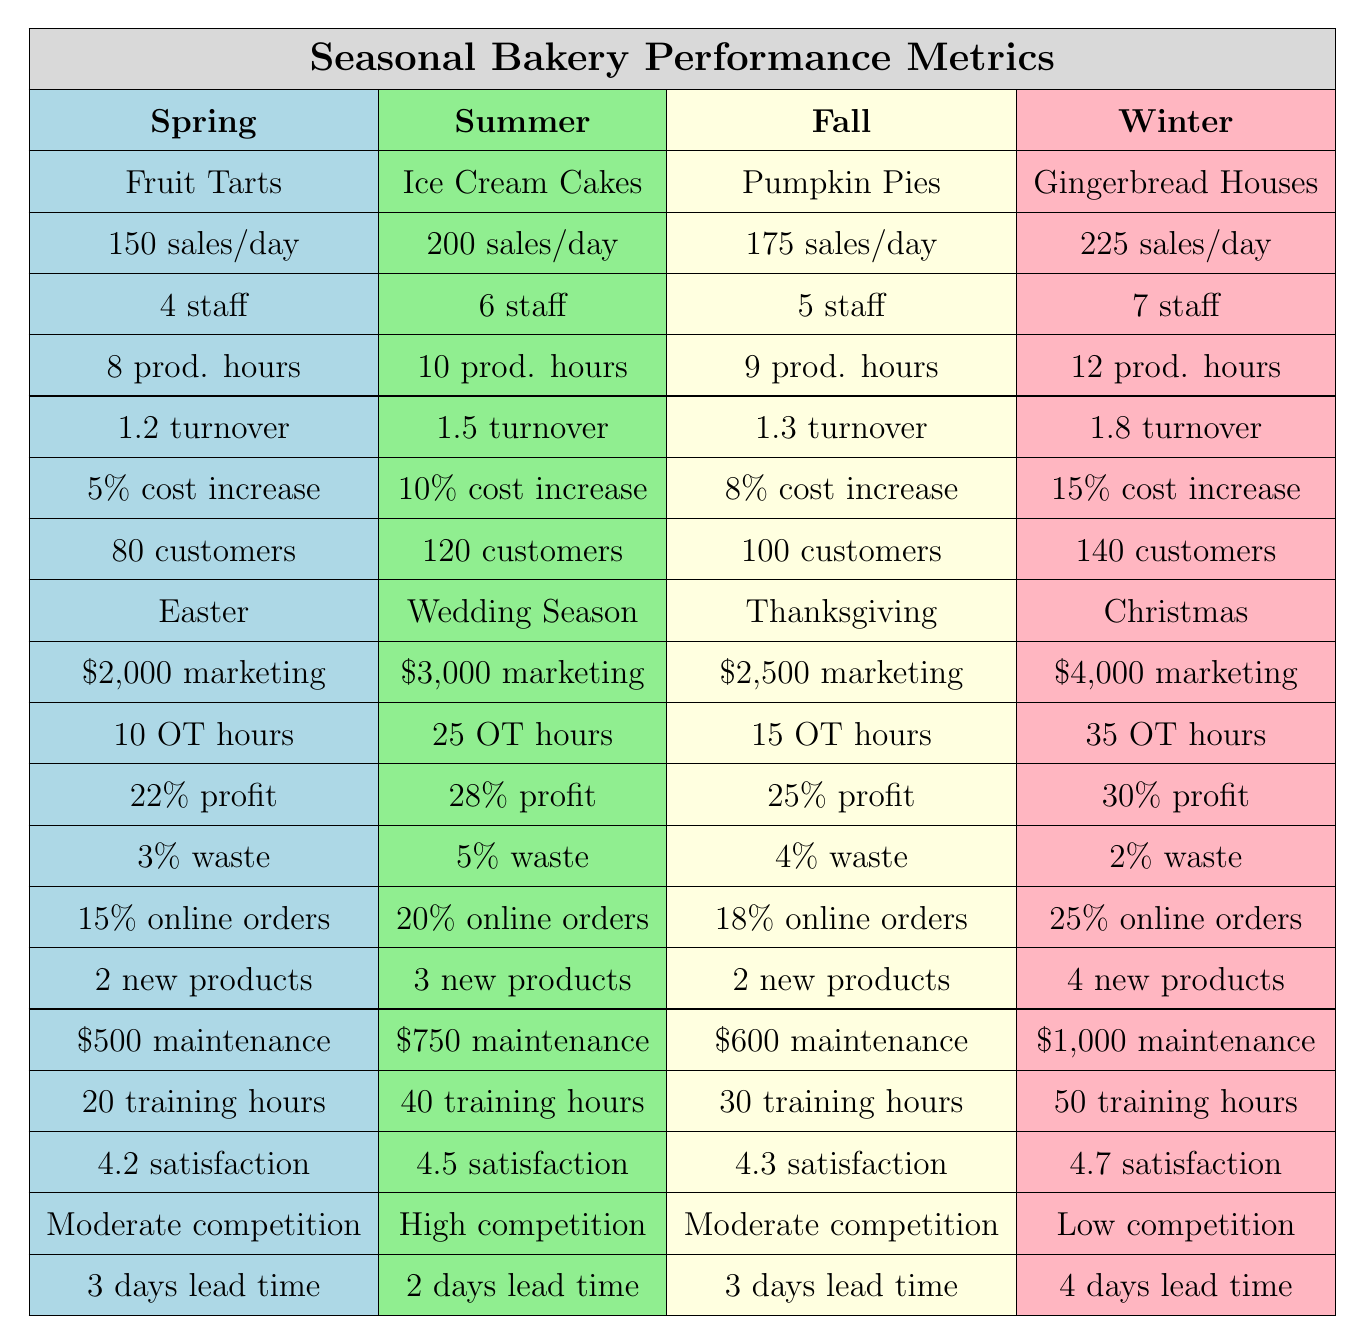What are the popular products in the Winter season? The table indicates that the popular product in the Winter season is Gingerbread Houses.
Answer: Gingerbread Houses Which season has the highest average daily sales? By comparing the average daily sales across all seasons, Winter has the highest sales at 225 per day.
Answer: Winter What is the average profit margin across all seasons? The profit margins are: 22%, 28%, 25%, and 30%. The average is calculated as (22 + 28 + 25 + 30) / 4 = 26.25%.
Answer: 26.25% How many staff are required during the Summer season? According to the table, the Summer season requires 6 staff members.
Answer: 6 Is the raw material cost increase highest in Fall compared to other seasons? The raw material cost increases are: 5% in Spring, 10% in Summer, 8% in Fall, and 15% in Winter. Comparing these, Winter has the highest increase, not Fall.
Answer: No What is the total overtime hours required in Spring and Fall combined? The overtime hours for Spring are 10 and for Fall are 15. Combining these gives 10 + 15 = 25 overtime hours.
Answer: 25 In which season is customer foot traffic highest? The customer foot traffic numbers are 80 (Spring), 120 (Summer), 100 (Fall), and 140 (Winter). Winter has the highest foot traffic at 140.
Answer: Winter What is the difference in production hours between Summer and Spring? The production hours for Summer are 10 and for Spring are 8. The difference is 10 - 8 = 2 hours.
Answer: 2 hours How many new products are introduced in Winter compared to Spring? The table shows 2 new products in Spring and 4 in Winter. The difference is 4 - 2 = 2 new products.
Answer: 2 Is there a correlation between the marketing budget and average daily sales? By examining the values, higher marketing budgets tend to align with higher sales. For example, Spring has a budget of $2,000 and sales of 150, while Winter has $4,000 and sales of 225, showing a tendency.
Answer: Yes 